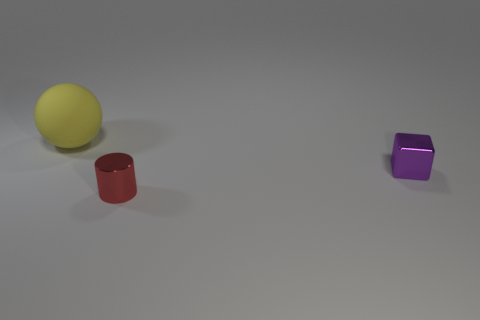Add 3 red rubber cylinders. How many objects exist? 6 Subtract all balls. How many objects are left? 2 Add 3 large balls. How many large balls exist? 4 Subtract 0 red balls. How many objects are left? 3 Subtract all metal cylinders. Subtract all tiny things. How many objects are left? 0 Add 3 tiny objects. How many tiny objects are left? 5 